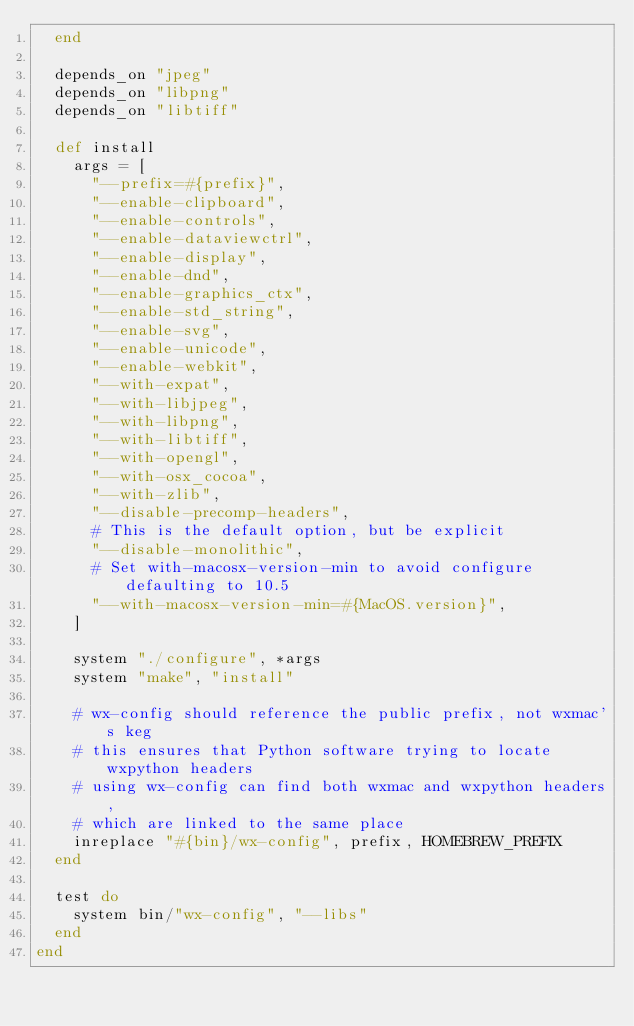<code> <loc_0><loc_0><loc_500><loc_500><_Ruby_>  end

  depends_on "jpeg"
  depends_on "libpng"
  depends_on "libtiff"

  def install
    args = [
      "--prefix=#{prefix}",
      "--enable-clipboard",
      "--enable-controls",
      "--enable-dataviewctrl",
      "--enable-display",
      "--enable-dnd",
      "--enable-graphics_ctx",
      "--enable-std_string",
      "--enable-svg",
      "--enable-unicode",
      "--enable-webkit",
      "--with-expat",
      "--with-libjpeg",
      "--with-libpng",
      "--with-libtiff",
      "--with-opengl",
      "--with-osx_cocoa",
      "--with-zlib",
      "--disable-precomp-headers",
      # This is the default option, but be explicit
      "--disable-monolithic",
      # Set with-macosx-version-min to avoid configure defaulting to 10.5
      "--with-macosx-version-min=#{MacOS.version}",
    ]

    system "./configure", *args
    system "make", "install"

    # wx-config should reference the public prefix, not wxmac's keg
    # this ensures that Python software trying to locate wxpython headers
    # using wx-config can find both wxmac and wxpython headers,
    # which are linked to the same place
    inreplace "#{bin}/wx-config", prefix, HOMEBREW_PREFIX
  end

  test do
    system bin/"wx-config", "--libs"
  end
end
</code> 